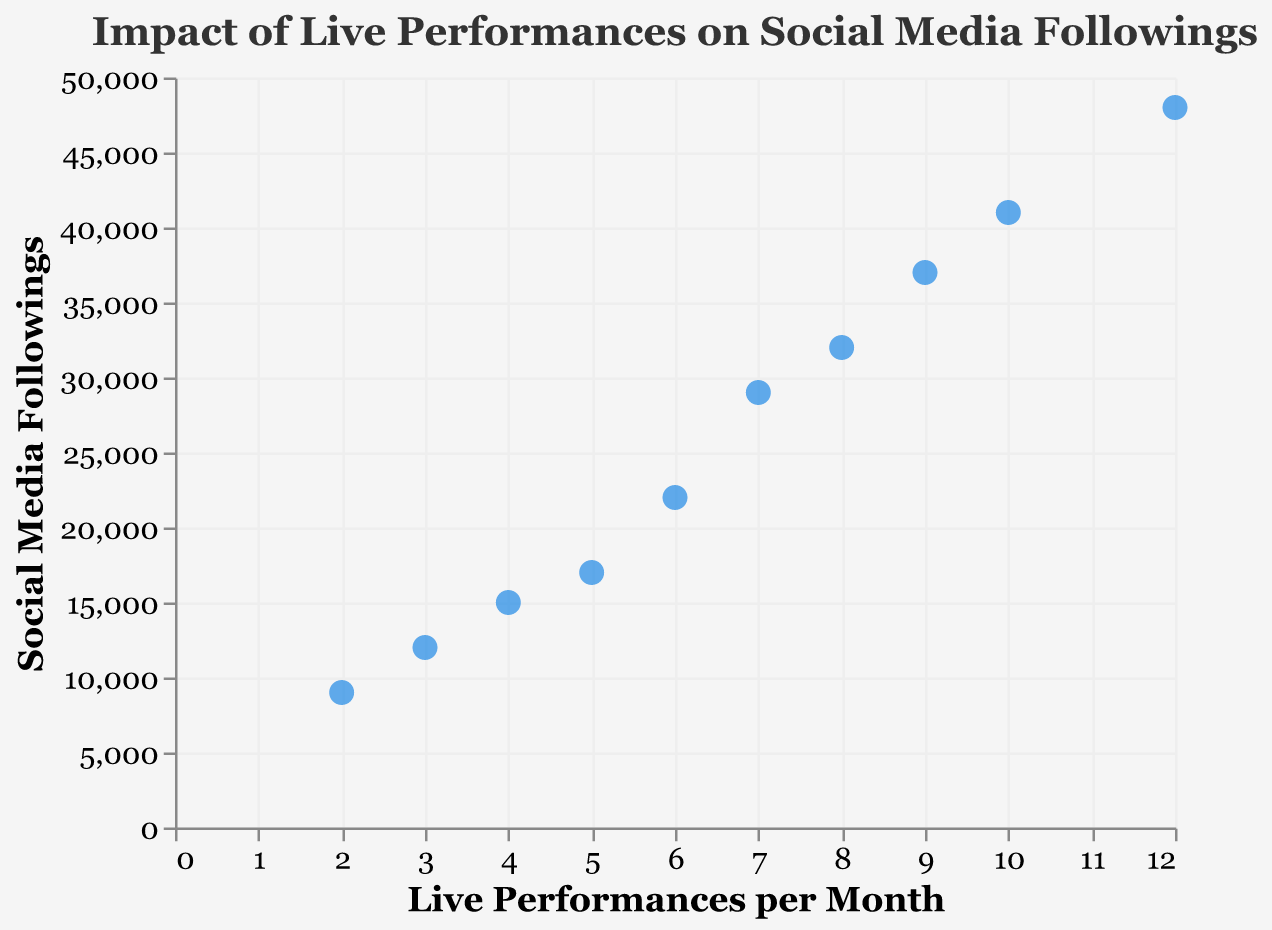What's the title of the scatter plot? The title of the scatter plot is present at the top of the figure and readable directly.
Answer: Impact of Live Performances on Social Media Followings How many musicians have more than 5 live performances per month? Count the number of musicians with "Live Performances per Month" values greater than 5.
Answer: 6 Which musician has the highest social media following? Identify the point with the highest value on the y-axis and check the tooltip for the musician's name.
Answer: Eddie "Bongo" Brown What is the average number of live performances per month among the musicians? Sum the "Live Performances per Month" for all musicians and divide by the total number of musicians. (8+4+12+7+3+10+5+6+2+9)/10 = 6.6
Answer: 6.6 Is there a general trend between the number of live performances and social media followings? Observe the overall pattern of the scatter points to determine if there is a visible trend, such as an upward or downward direction.
Answer: Positive correlation Which musician performs the least number of live performances per month, and what is their social media following? Identify the point with the lowest value on the x-axis and check the tooltip for the musician's name and social media following.
Answer: Bob Babbitt, 9000 How many musicians have more than 20,000 social media followings? Count the number of musicians with "Social Media Followings" values greater than 20,000.
Answer: 6 Who has more social media followings: Joe Messina or Jack Ashford? Compare the y-values of Joe Messina and Jack Ashford to determine who has more social media followings.
Answer: Joe Messina What is the range of live performances per month for these musicians? Subtract the smallest value of "Live Performances per Month" from the largest value. 12 - 2 = 10
Answer: 10 How does the social media following of Uriel Jones compare to Earl Van Dyke? Compare the y-values for Uriel Jones and Earl Van Dyke to determine who has a higher following.
Answer: Uriel Jones 